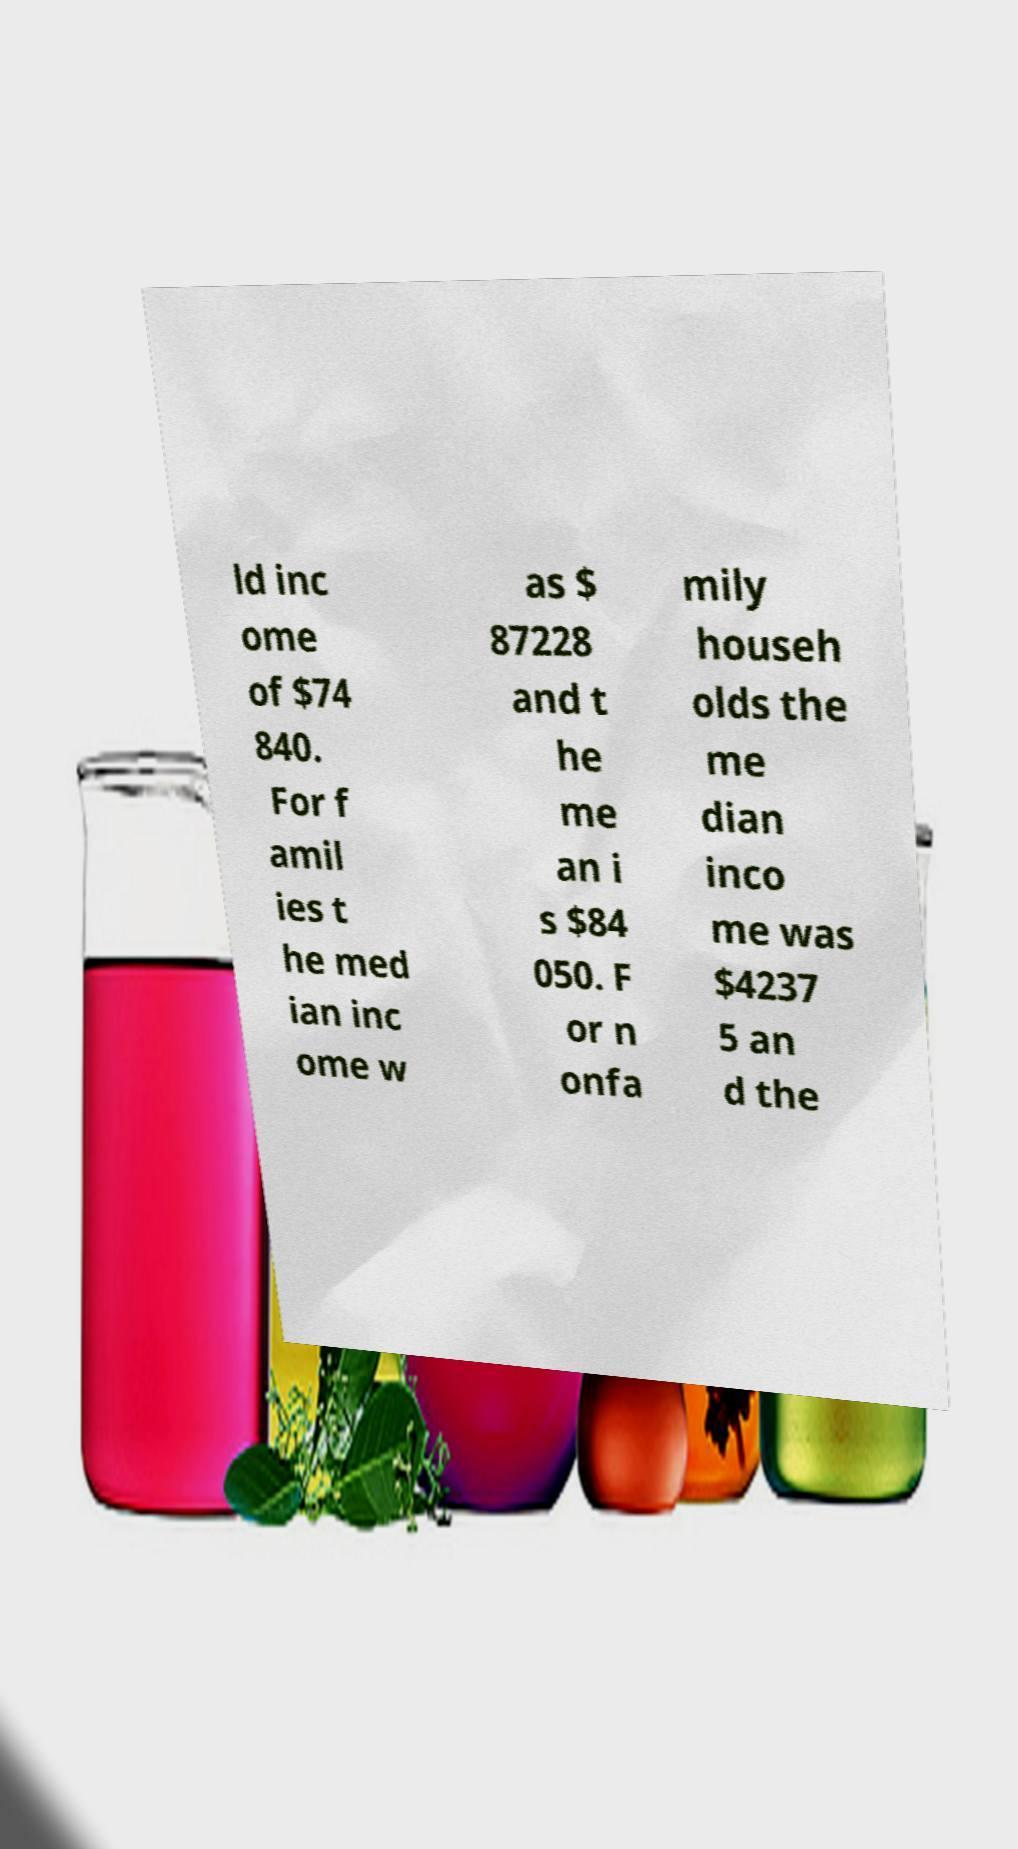Could you assist in decoding the text presented in this image and type it out clearly? ld inc ome of $74 840. For f amil ies t he med ian inc ome w as $ 87228 and t he me an i s $84 050. F or n onfa mily househ olds the me dian inco me was $4237 5 an d the 